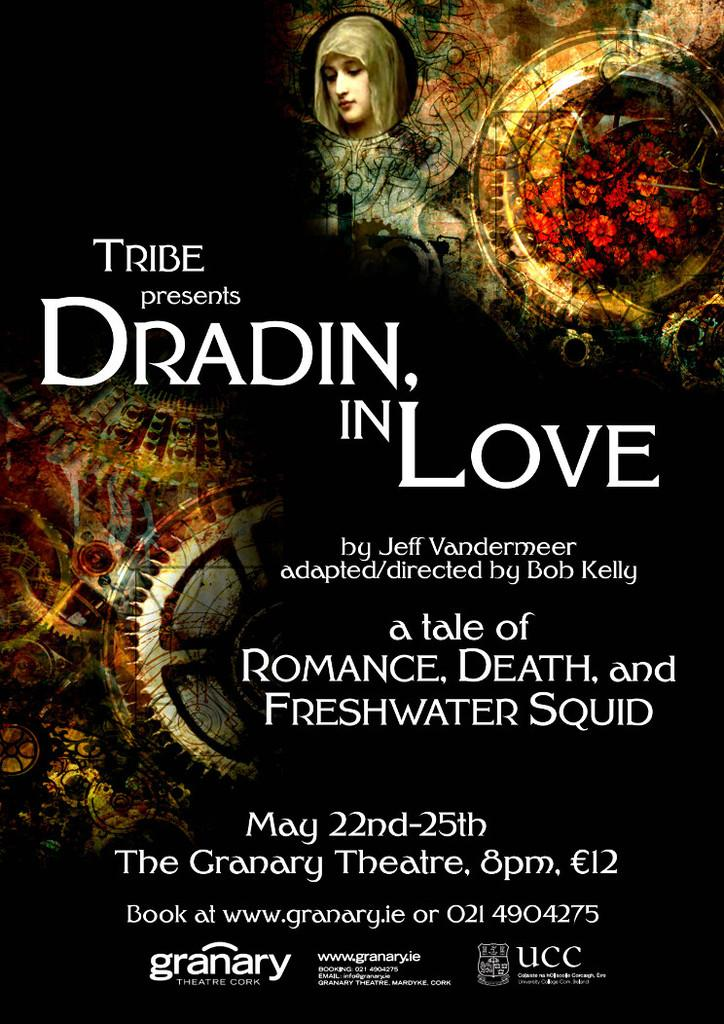<image>
Present a compact description of the photo's key features. An advertisement for Dradin in Love which is playing at The Granary Theatre. 